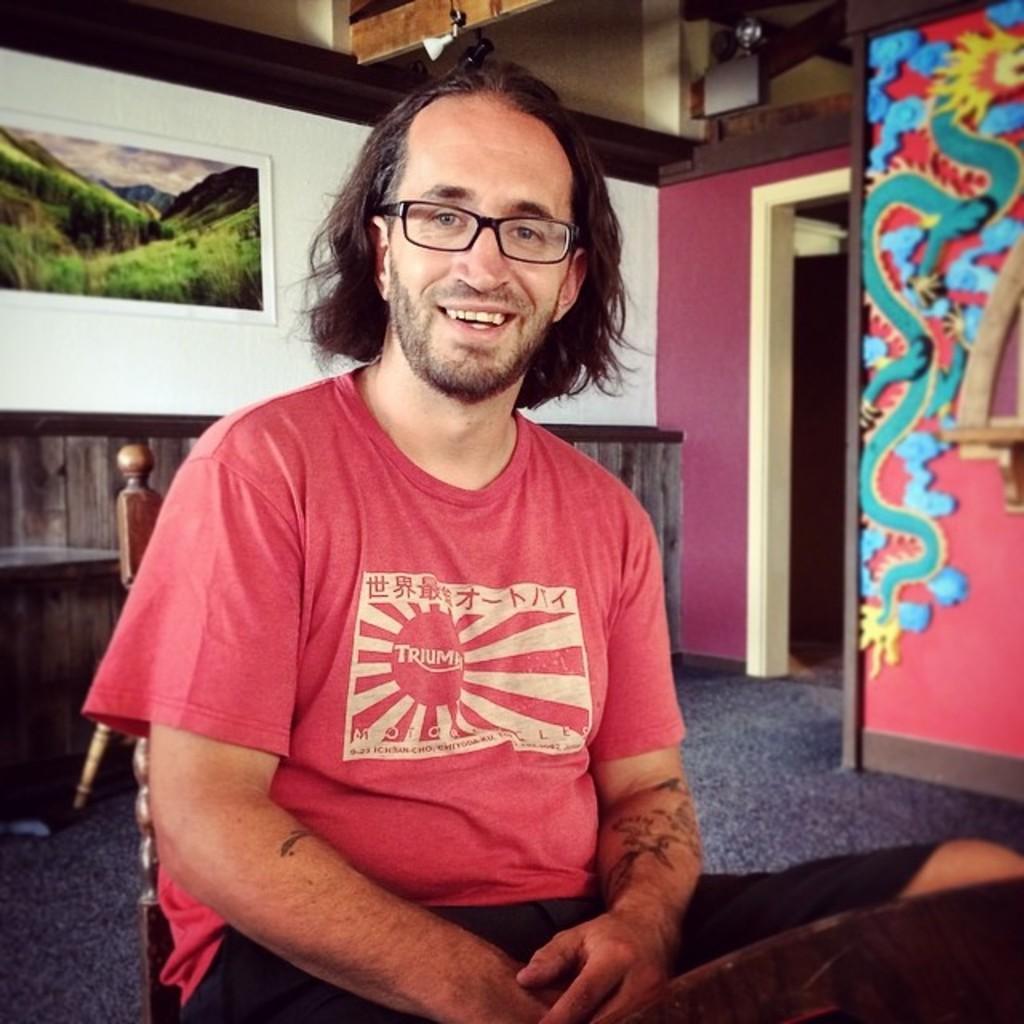Please provide a concise description of this image. In this image, we can see a man is seeing and smiling. He wore glasses and t shirt. He is sitting on the chair. Background we can see floor, wall and photo frame. 